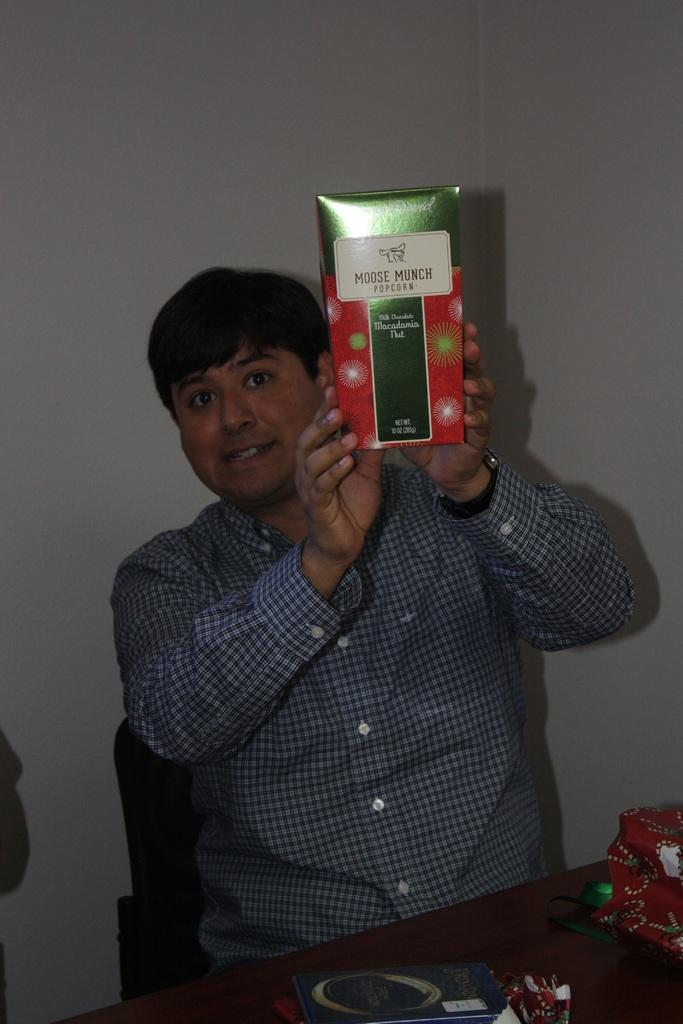Provide a one-sentence caption for the provided image. a man holding up a box of Moose Munch. 